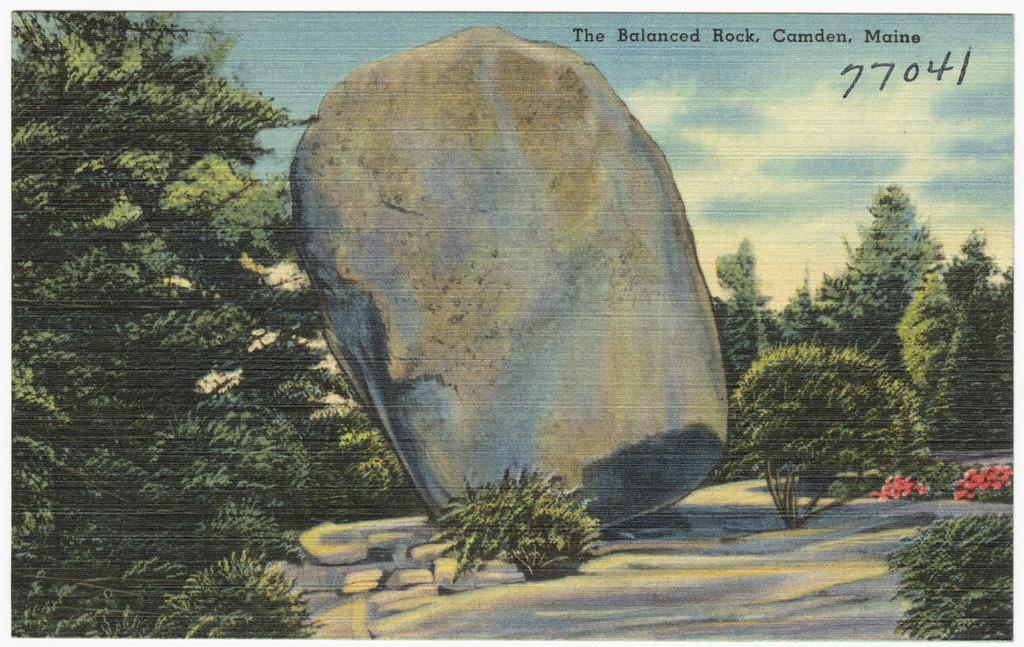<image>
Describe the image concisely. the numbers 77041 on the front of a painting 